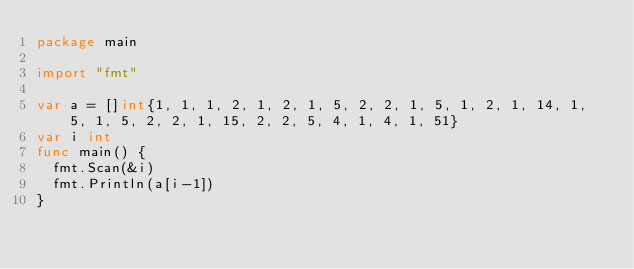Convert code to text. <code><loc_0><loc_0><loc_500><loc_500><_Go_>package main

import "fmt"

var a = []int{1, 1, 1, 2, 1, 2, 1, 5, 2, 2, 1, 5, 1, 2, 1, 14, 1, 5, 1, 5, 2, 2, 1, 15, 2, 2, 5, 4, 1, 4, 1, 51}
var i int
func main() {
	fmt.Scan(&i)
	fmt.Println(a[i-1])
}
</code> 